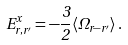Convert formula to latex. <formula><loc_0><loc_0><loc_500><loc_500>E _ { r , r ^ { \prime } } ^ { x } = - \frac { 3 } { 2 } \langle \Omega _ { r - r ^ { \prime } } \rangle \, .</formula> 